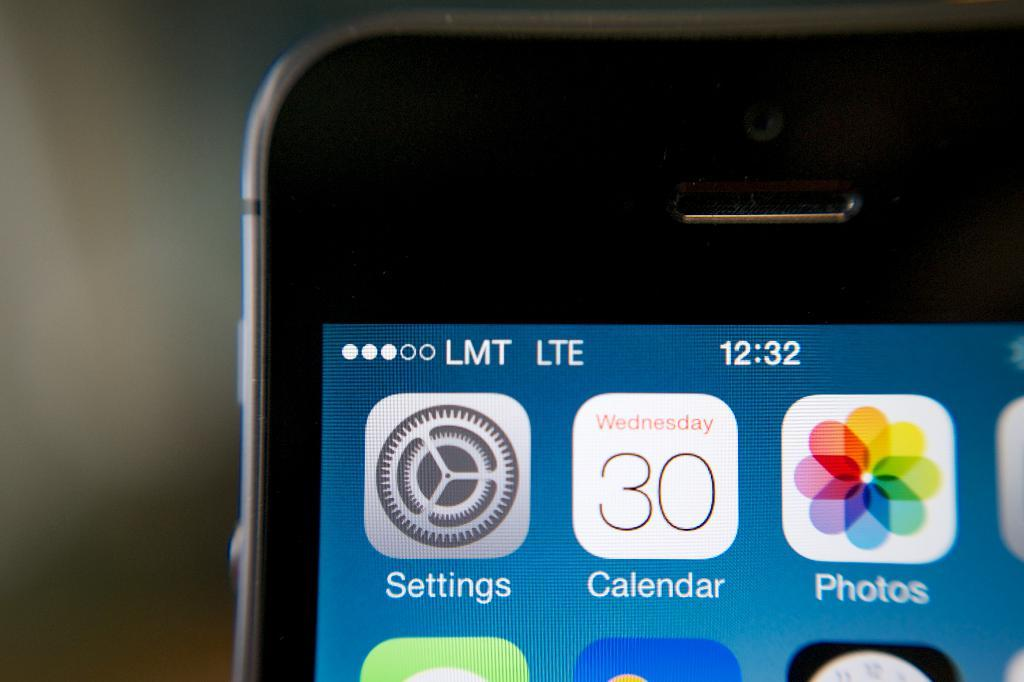<image>
Give a short and clear explanation of the subsequent image. an iphone showing setting and a calendar date with 30 along with a 12:32 time 